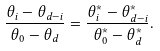<formula> <loc_0><loc_0><loc_500><loc_500>\frac { \theta _ { i } - \theta _ { d - i } } { \theta _ { 0 } - \theta _ { d } } = \frac { \theta ^ { * } _ { i } - \theta ^ { * } _ { d - i } } { \theta ^ { * } _ { 0 } - \theta ^ { * } _ { d } } .</formula> 